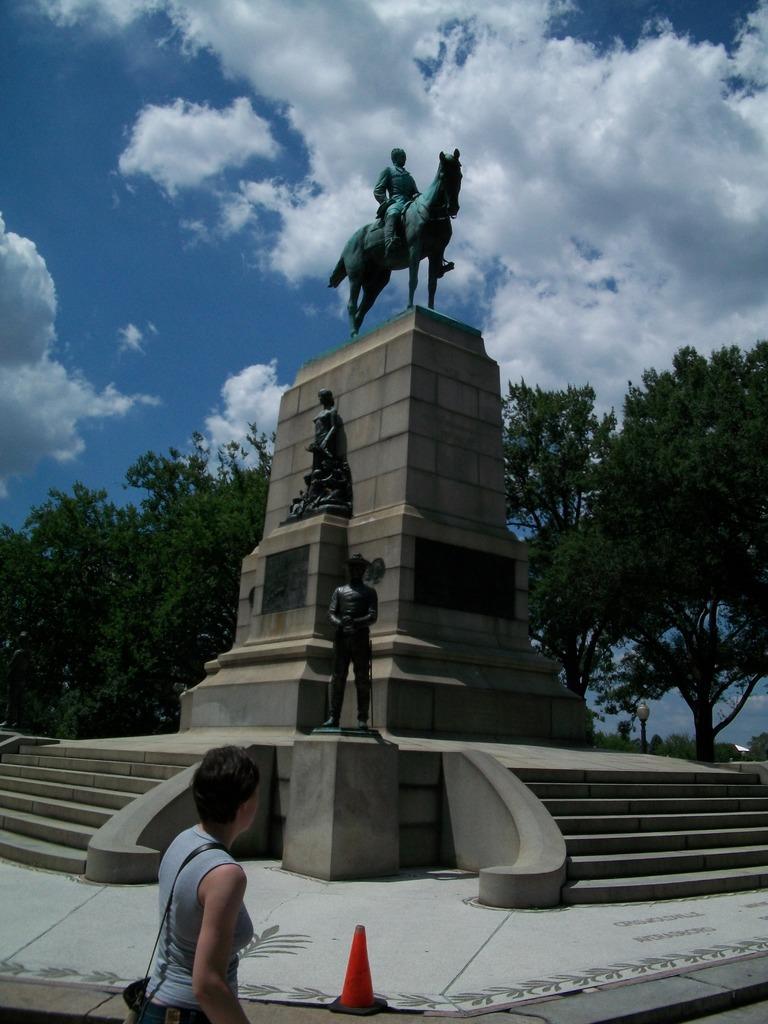How would you summarize this image in a sentence or two? This is a person standing. These are the sculptures, which are on the pillar. I can see the stairs. These are the trees with branches and leaves. I can see the clouds in the sky. 